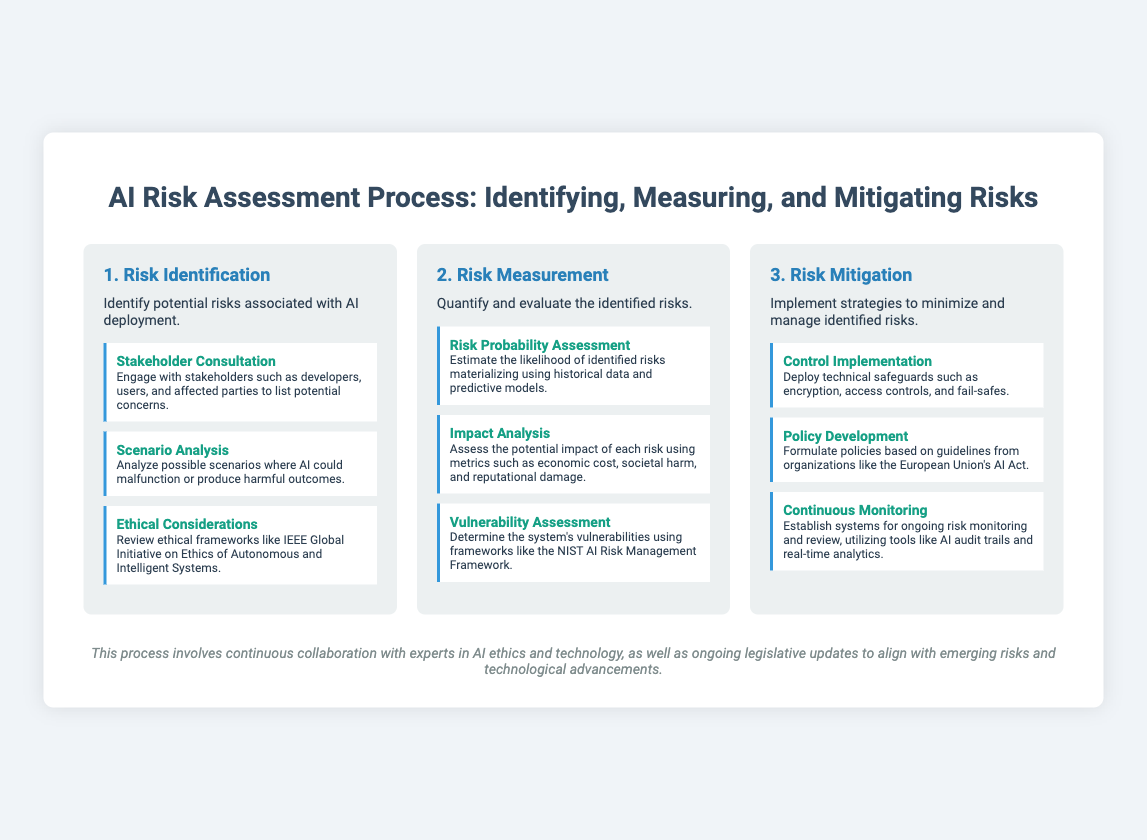What is the first step in the AI Risk Assessment Process? The first step is clearly defined in the document as "Risk Identification."
Answer: Risk Identification What does the second step focus on? The document states that the second step is about quantifying and evaluating identified risks.
Answer: Risk Measurement Name one substep under Risk Identification. The document lists "Stakeholder Consultation" as one of the substeps.
Answer: Stakeholder Consultation What is assessed in the Impact Analysis substep? The Impact Analysis substep involves assessing potential impacts using specific metrics outlined in the document.
Answer: Economic cost, societal harm, and reputational damage What is the purpose of Continuous Monitoring in the Risk Mitigation step? The document describes Continuous Monitoring as a system for ongoing risk monitoring and review.
Answer: Ongoing risk monitoring and review Which framework is mentioned for Vulnerability Assessment? The document mentions the NIST AI Risk Management Framework as a reference for conducting Vulnerability Assessment.
Answer: NIST AI Risk Management Framework What is one of the controls that can be implemented according to the Risk Mitigation step? The substep "Control Implementation" emphasizes deploying technical safeguards.
Answer: Technical safeguards Which organization's guidelines influence Policy Development? The document references the European Union's AI Act as a basis for policy formulation.
Answer: European Union's AI Act How does the process described in the document emphasize collaboration? The closing statement highlights the importance of collaboration with AI ethics and technology experts.
Answer: Continuous collaboration with experts in AI ethics and technology 